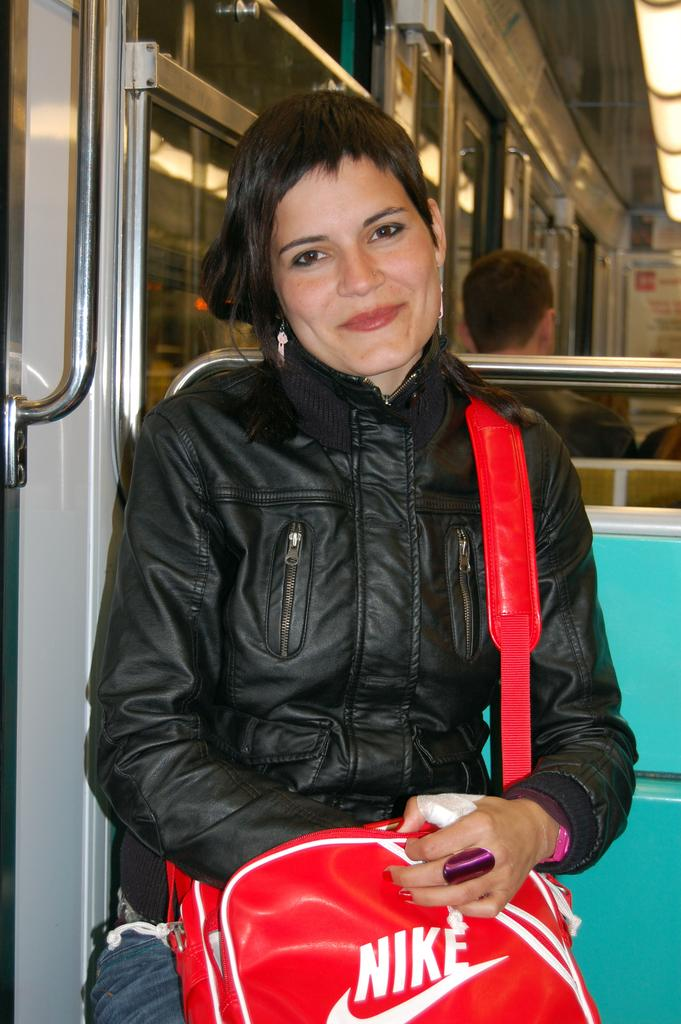<image>
Create a compact narrative representing the image presented. a lady that is wearing a Nike bag on her shoulder 